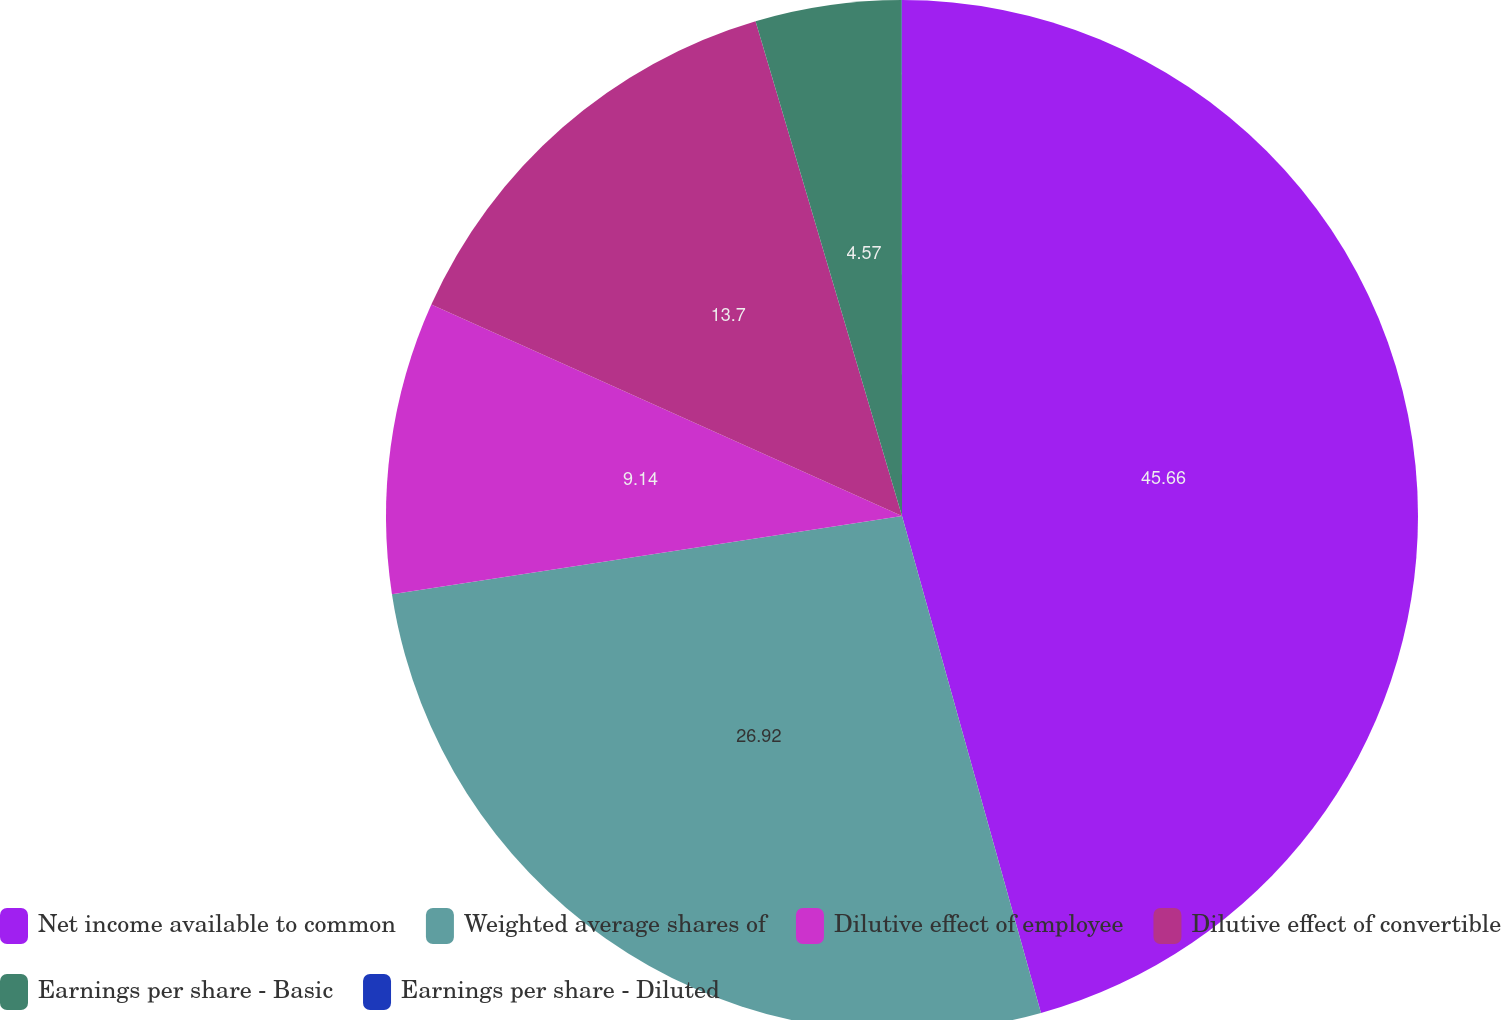<chart> <loc_0><loc_0><loc_500><loc_500><pie_chart><fcel>Net income available to common<fcel>Weighted average shares of<fcel>Dilutive effect of employee<fcel>Dilutive effect of convertible<fcel>Earnings per share - Basic<fcel>Earnings per share - Diluted<nl><fcel>45.66%<fcel>26.92%<fcel>9.14%<fcel>13.7%<fcel>4.57%<fcel>0.01%<nl></chart> 